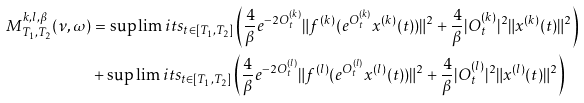<formula> <loc_0><loc_0><loc_500><loc_500>M _ { T _ { 1 } , T _ { 2 } } ^ { k , l , \beta } ( \nu , \omega ) & = \sup \lim i t s _ { t \in [ T _ { 1 } , T _ { 2 } ] } \left ( \frac { 4 } { \beta } e ^ { - 2 O _ { t } ^ { ( k ) } } \| f ^ { ( k ) } ( e ^ { O _ { t } ^ { ( k ) } } x ^ { ( k ) } ( t ) ) \| ^ { 2 } + \frac { 4 } { \beta } | O _ { t } ^ { ( k ) } | ^ { 2 } \| x ^ { ( k ) } ( t ) \| ^ { 2 } \right ) \\ & + \sup \lim i t s _ { t \in [ T _ { 1 } , T _ { 2 } ] } \left ( \frac { 4 } { \beta } e ^ { - 2 O _ { t } ^ { ( l ) } } \| f ^ { ( l ) } ( e ^ { O _ { t } ^ { ( l ) } } x ^ { ( l ) } ( t ) ) \| ^ { 2 } + \frac { 4 } { \beta } | O _ { t } ^ { ( l ) } | ^ { 2 } \| x ^ { ( l ) } ( t ) \| ^ { 2 } \right )</formula> 